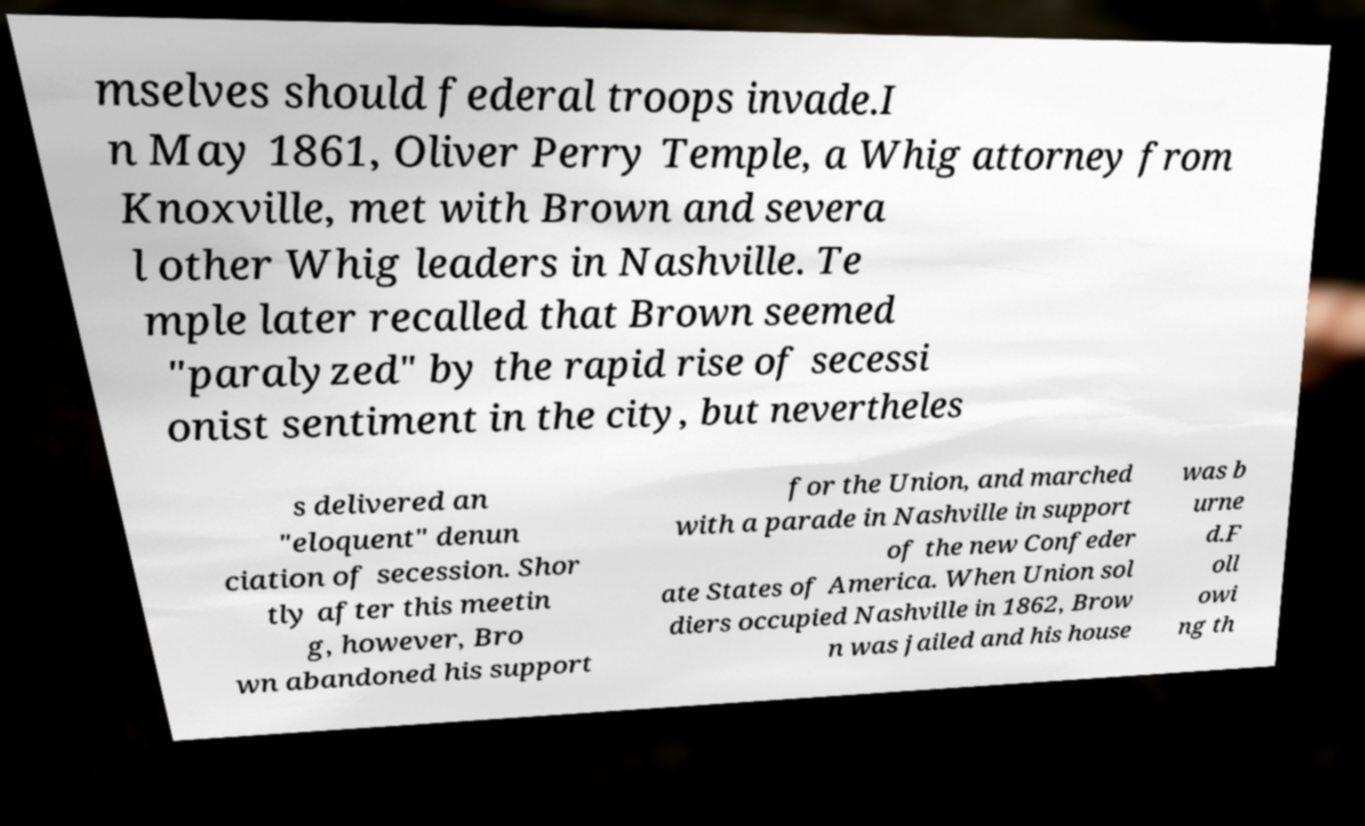There's text embedded in this image that I need extracted. Can you transcribe it verbatim? mselves should federal troops invade.I n May 1861, Oliver Perry Temple, a Whig attorney from Knoxville, met with Brown and severa l other Whig leaders in Nashville. Te mple later recalled that Brown seemed "paralyzed" by the rapid rise of secessi onist sentiment in the city, but nevertheles s delivered an "eloquent" denun ciation of secession. Shor tly after this meetin g, however, Bro wn abandoned his support for the Union, and marched with a parade in Nashville in support of the new Confeder ate States of America. When Union sol diers occupied Nashville in 1862, Brow n was jailed and his house was b urne d.F oll owi ng th 